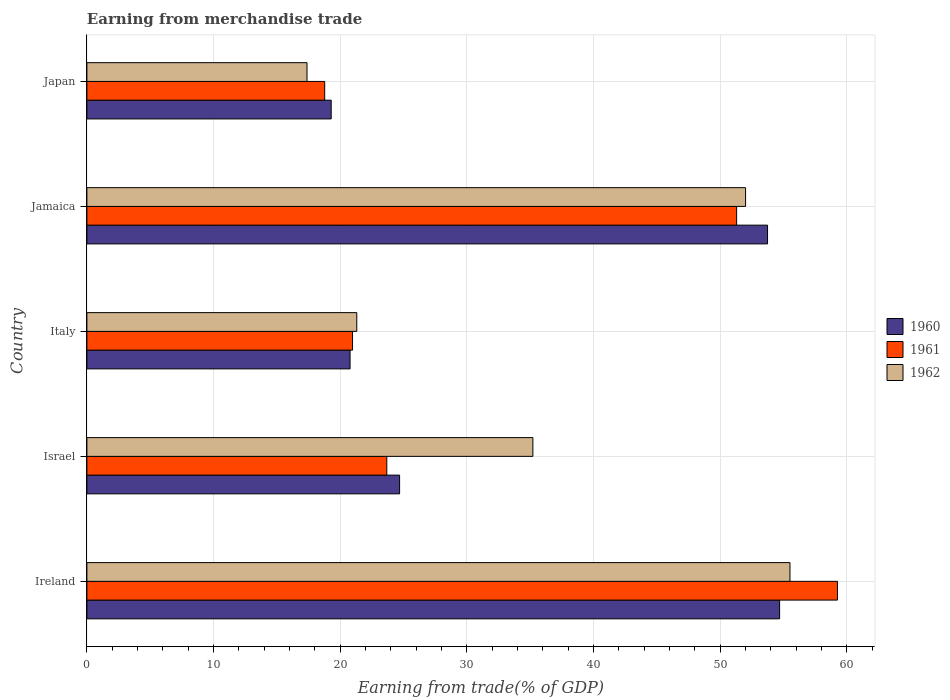Are the number of bars per tick equal to the number of legend labels?
Keep it short and to the point. Yes. Are the number of bars on each tick of the Y-axis equal?
Provide a short and direct response. Yes. How many bars are there on the 2nd tick from the top?
Keep it short and to the point. 3. What is the label of the 2nd group of bars from the top?
Ensure brevity in your answer.  Jamaica. In how many cases, is the number of bars for a given country not equal to the number of legend labels?
Ensure brevity in your answer.  0. What is the earnings from trade in 1962 in Ireland?
Your answer should be very brief. 55.51. Across all countries, what is the maximum earnings from trade in 1961?
Your answer should be very brief. 59.26. Across all countries, what is the minimum earnings from trade in 1962?
Provide a succinct answer. 17.38. In which country was the earnings from trade in 1960 maximum?
Ensure brevity in your answer.  Ireland. In which country was the earnings from trade in 1960 minimum?
Your answer should be very brief. Japan. What is the total earnings from trade in 1961 in the graph?
Keep it short and to the point. 173.98. What is the difference between the earnings from trade in 1962 in Israel and that in Italy?
Offer a terse response. 13.9. What is the difference between the earnings from trade in 1960 in Israel and the earnings from trade in 1962 in Ireland?
Give a very brief answer. -30.82. What is the average earnings from trade in 1960 per country?
Provide a succinct answer. 34.64. What is the difference between the earnings from trade in 1962 and earnings from trade in 1961 in Ireland?
Provide a succinct answer. -3.75. What is the ratio of the earnings from trade in 1961 in Italy to that in Japan?
Your answer should be compact. 1.12. Is the difference between the earnings from trade in 1962 in Israel and Italy greater than the difference between the earnings from trade in 1961 in Israel and Italy?
Make the answer very short. Yes. What is the difference between the highest and the second highest earnings from trade in 1961?
Offer a terse response. 7.96. What is the difference between the highest and the lowest earnings from trade in 1962?
Ensure brevity in your answer.  38.13. What does the 1st bar from the bottom in Italy represents?
Give a very brief answer. 1960. How many bars are there?
Provide a succinct answer. 15. How many countries are there in the graph?
Make the answer very short. 5. What is the difference between two consecutive major ticks on the X-axis?
Offer a very short reply. 10. Are the values on the major ticks of X-axis written in scientific E-notation?
Make the answer very short. No. Does the graph contain grids?
Keep it short and to the point. Yes. Where does the legend appear in the graph?
Ensure brevity in your answer.  Center right. How many legend labels are there?
Your response must be concise. 3. How are the legend labels stacked?
Your answer should be compact. Vertical. What is the title of the graph?
Offer a terse response. Earning from merchandise trade. What is the label or title of the X-axis?
Ensure brevity in your answer.  Earning from trade(% of GDP). What is the Earning from trade(% of GDP) of 1960 in Ireland?
Make the answer very short. 54.69. What is the Earning from trade(% of GDP) in 1961 in Ireland?
Make the answer very short. 59.26. What is the Earning from trade(% of GDP) of 1962 in Ireland?
Your response must be concise. 55.51. What is the Earning from trade(% of GDP) of 1960 in Israel?
Keep it short and to the point. 24.69. What is the Earning from trade(% of GDP) of 1961 in Israel?
Provide a succinct answer. 23.68. What is the Earning from trade(% of GDP) of 1962 in Israel?
Your response must be concise. 35.21. What is the Earning from trade(% of GDP) in 1960 in Italy?
Provide a succinct answer. 20.78. What is the Earning from trade(% of GDP) of 1961 in Italy?
Your answer should be very brief. 20.97. What is the Earning from trade(% of GDP) in 1962 in Italy?
Your response must be concise. 21.31. What is the Earning from trade(% of GDP) in 1960 in Jamaica?
Provide a succinct answer. 53.74. What is the Earning from trade(% of GDP) of 1961 in Jamaica?
Provide a succinct answer. 51.3. What is the Earning from trade(% of GDP) in 1962 in Jamaica?
Your response must be concise. 52. What is the Earning from trade(% of GDP) in 1960 in Japan?
Provide a succinct answer. 19.29. What is the Earning from trade(% of GDP) of 1961 in Japan?
Provide a short and direct response. 18.77. What is the Earning from trade(% of GDP) of 1962 in Japan?
Make the answer very short. 17.38. Across all countries, what is the maximum Earning from trade(% of GDP) in 1960?
Your answer should be very brief. 54.69. Across all countries, what is the maximum Earning from trade(% of GDP) in 1961?
Your response must be concise. 59.26. Across all countries, what is the maximum Earning from trade(% of GDP) in 1962?
Provide a succinct answer. 55.51. Across all countries, what is the minimum Earning from trade(% of GDP) in 1960?
Provide a succinct answer. 19.29. Across all countries, what is the minimum Earning from trade(% of GDP) of 1961?
Provide a short and direct response. 18.77. Across all countries, what is the minimum Earning from trade(% of GDP) of 1962?
Offer a very short reply. 17.38. What is the total Earning from trade(% of GDP) of 1960 in the graph?
Keep it short and to the point. 173.18. What is the total Earning from trade(% of GDP) of 1961 in the graph?
Your answer should be compact. 173.98. What is the total Earning from trade(% of GDP) of 1962 in the graph?
Your response must be concise. 181.41. What is the difference between the Earning from trade(% of GDP) in 1960 in Ireland and that in Israel?
Offer a very short reply. 30. What is the difference between the Earning from trade(% of GDP) of 1961 in Ireland and that in Israel?
Your response must be concise. 35.58. What is the difference between the Earning from trade(% of GDP) of 1962 in Ireland and that in Israel?
Offer a terse response. 20.3. What is the difference between the Earning from trade(% of GDP) of 1960 in Ireland and that in Italy?
Provide a succinct answer. 33.91. What is the difference between the Earning from trade(% of GDP) of 1961 in Ireland and that in Italy?
Your response must be concise. 38.29. What is the difference between the Earning from trade(% of GDP) in 1962 in Ireland and that in Italy?
Give a very brief answer. 34.2. What is the difference between the Earning from trade(% of GDP) of 1960 in Ireland and that in Jamaica?
Offer a very short reply. 0.95. What is the difference between the Earning from trade(% of GDP) of 1961 in Ireland and that in Jamaica?
Keep it short and to the point. 7.96. What is the difference between the Earning from trade(% of GDP) of 1962 in Ireland and that in Jamaica?
Provide a short and direct response. 3.5. What is the difference between the Earning from trade(% of GDP) in 1960 in Ireland and that in Japan?
Offer a terse response. 35.4. What is the difference between the Earning from trade(% of GDP) in 1961 in Ireland and that in Japan?
Keep it short and to the point. 40.48. What is the difference between the Earning from trade(% of GDP) of 1962 in Ireland and that in Japan?
Make the answer very short. 38.13. What is the difference between the Earning from trade(% of GDP) in 1960 in Israel and that in Italy?
Your response must be concise. 3.91. What is the difference between the Earning from trade(% of GDP) in 1961 in Israel and that in Italy?
Offer a terse response. 2.71. What is the difference between the Earning from trade(% of GDP) of 1962 in Israel and that in Italy?
Offer a terse response. 13.9. What is the difference between the Earning from trade(% of GDP) in 1960 in Israel and that in Jamaica?
Provide a succinct answer. -29.05. What is the difference between the Earning from trade(% of GDP) in 1961 in Israel and that in Jamaica?
Offer a very short reply. -27.62. What is the difference between the Earning from trade(% of GDP) of 1962 in Israel and that in Jamaica?
Your answer should be very brief. -16.79. What is the difference between the Earning from trade(% of GDP) of 1960 in Israel and that in Japan?
Offer a very short reply. 5.4. What is the difference between the Earning from trade(% of GDP) in 1961 in Israel and that in Japan?
Give a very brief answer. 4.9. What is the difference between the Earning from trade(% of GDP) of 1962 in Israel and that in Japan?
Your answer should be very brief. 17.83. What is the difference between the Earning from trade(% of GDP) of 1960 in Italy and that in Jamaica?
Your answer should be very brief. -32.96. What is the difference between the Earning from trade(% of GDP) in 1961 in Italy and that in Jamaica?
Offer a very short reply. -30.32. What is the difference between the Earning from trade(% of GDP) in 1962 in Italy and that in Jamaica?
Offer a very short reply. -30.7. What is the difference between the Earning from trade(% of GDP) in 1960 in Italy and that in Japan?
Ensure brevity in your answer.  1.49. What is the difference between the Earning from trade(% of GDP) in 1961 in Italy and that in Japan?
Ensure brevity in your answer.  2.2. What is the difference between the Earning from trade(% of GDP) of 1962 in Italy and that in Japan?
Your answer should be compact. 3.93. What is the difference between the Earning from trade(% of GDP) of 1960 in Jamaica and that in Japan?
Your answer should be compact. 34.45. What is the difference between the Earning from trade(% of GDP) of 1961 in Jamaica and that in Japan?
Offer a very short reply. 32.52. What is the difference between the Earning from trade(% of GDP) of 1962 in Jamaica and that in Japan?
Give a very brief answer. 34.63. What is the difference between the Earning from trade(% of GDP) in 1960 in Ireland and the Earning from trade(% of GDP) in 1961 in Israel?
Give a very brief answer. 31.01. What is the difference between the Earning from trade(% of GDP) of 1960 in Ireland and the Earning from trade(% of GDP) of 1962 in Israel?
Your answer should be compact. 19.48. What is the difference between the Earning from trade(% of GDP) in 1961 in Ireland and the Earning from trade(% of GDP) in 1962 in Israel?
Offer a terse response. 24.05. What is the difference between the Earning from trade(% of GDP) in 1960 in Ireland and the Earning from trade(% of GDP) in 1961 in Italy?
Offer a terse response. 33.72. What is the difference between the Earning from trade(% of GDP) in 1960 in Ireland and the Earning from trade(% of GDP) in 1962 in Italy?
Give a very brief answer. 33.38. What is the difference between the Earning from trade(% of GDP) in 1961 in Ireland and the Earning from trade(% of GDP) in 1962 in Italy?
Provide a short and direct response. 37.95. What is the difference between the Earning from trade(% of GDP) in 1960 in Ireland and the Earning from trade(% of GDP) in 1961 in Jamaica?
Your answer should be very brief. 3.39. What is the difference between the Earning from trade(% of GDP) in 1960 in Ireland and the Earning from trade(% of GDP) in 1962 in Jamaica?
Your response must be concise. 2.69. What is the difference between the Earning from trade(% of GDP) in 1961 in Ireland and the Earning from trade(% of GDP) in 1962 in Jamaica?
Keep it short and to the point. 7.25. What is the difference between the Earning from trade(% of GDP) of 1960 in Ireland and the Earning from trade(% of GDP) of 1961 in Japan?
Provide a succinct answer. 35.92. What is the difference between the Earning from trade(% of GDP) of 1960 in Ireland and the Earning from trade(% of GDP) of 1962 in Japan?
Keep it short and to the point. 37.31. What is the difference between the Earning from trade(% of GDP) of 1961 in Ireland and the Earning from trade(% of GDP) of 1962 in Japan?
Ensure brevity in your answer.  41.88. What is the difference between the Earning from trade(% of GDP) in 1960 in Israel and the Earning from trade(% of GDP) in 1961 in Italy?
Make the answer very short. 3.72. What is the difference between the Earning from trade(% of GDP) of 1960 in Israel and the Earning from trade(% of GDP) of 1962 in Italy?
Your answer should be very brief. 3.38. What is the difference between the Earning from trade(% of GDP) in 1961 in Israel and the Earning from trade(% of GDP) in 1962 in Italy?
Ensure brevity in your answer.  2.37. What is the difference between the Earning from trade(% of GDP) in 1960 in Israel and the Earning from trade(% of GDP) in 1961 in Jamaica?
Offer a terse response. -26.61. What is the difference between the Earning from trade(% of GDP) in 1960 in Israel and the Earning from trade(% of GDP) in 1962 in Jamaica?
Your answer should be very brief. -27.32. What is the difference between the Earning from trade(% of GDP) in 1961 in Israel and the Earning from trade(% of GDP) in 1962 in Jamaica?
Offer a terse response. -28.33. What is the difference between the Earning from trade(% of GDP) of 1960 in Israel and the Earning from trade(% of GDP) of 1961 in Japan?
Give a very brief answer. 5.91. What is the difference between the Earning from trade(% of GDP) in 1960 in Israel and the Earning from trade(% of GDP) in 1962 in Japan?
Give a very brief answer. 7.31. What is the difference between the Earning from trade(% of GDP) in 1961 in Israel and the Earning from trade(% of GDP) in 1962 in Japan?
Offer a terse response. 6.3. What is the difference between the Earning from trade(% of GDP) in 1960 in Italy and the Earning from trade(% of GDP) in 1961 in Jamaica?
Make the answer very short. -30.52. What is the difference between the Earning from trade(% of GDP) in 1960 in Italy and the Earning from trade(% of GDP) in 1962 in Jamaica?
Your response must be concise. -31.23. What is the difference between the Earning from trade(% of GDP) of 1961 in Italy and the Earning from trade(% of GDP) of 1962 in Jamaica?
Keep it short and to the point. -31.03. What is the difference between the Earning from trade(% of GDP) in 1960 in Italy and the Earning from trade(% of GDP) in 1961 in Japan?
Offer a terse response. 2. What is the difference between the Earning from trade(% of GDP) of 1960 in Italy and the Earning from trade(% of GDP) of 1962 in Japan?
Keep it short and to the point. 3.4. What is the difference between the Earning from trade(% of GDP) of 1961 in Italy and the Earning from trade(% of GDP) of 1962 in Japan?
Provide a short and direct response. 3.59. What is the difference between the Earning from trade(% of GDP) of 1960 in Jamaica and the Earning from trade(% of GDP) of 1961 in Japan?
Your response must be concise. 34.96. What is the difference between the Earning from trade(% of GDP) of 1960 in Jamaica and the Earning from trade(% of GDP) of 1962 in Japan?
Keep it short and to the point. 36.36. What is the difference between the Earning from trade(% of GDP) of 1961 in Jamaica and the Earning from trade(% of GDP) of 1962 in Japan?
Offer a very short reply. 33.92. What is the average Earning from trade(% of GDP) of 1960 per country?
Keep it short and to the point. 34.64. What is the average Earning from trade(% of GDP) of 1961 per country?
Your answer should be compact. 34.8. What is the average Earning from trade(% of GDP) in 1962 per country?
Ensure brevity in your answer.  36.28. What is the difference between the Earning from trade(% of GDP) of 1960 and Earning from trade(% of GDP) of 1961 in Ireland?
Offer a terse response. -4.57. What is the difference between the Earning from trade(% of GDP) in 1960 and Earning from trade(% of GDP) in 1962 in Ireland?
Keep it short and to the point. -0.82. What is the difference between the Earning from trade(% of GDP) in 1961 and Earning from trade(% of GDP) in 1962 in Ireland?
Offer a very short reply. 3.75. What is the difference between the Earning from trade(% of GDP) of 1960 and Earning from trade(% of GDP) of 1961 in Israel?
Your response must be concise. 1.01. What is the difference between the Earning from trade(% of GDP) of 1960 and Earning from trade(% of GDP) of 1962 in Israel?
Offer a terse response. -10.52. What is the difference between the Earning from trade(% of GDP) of 1961 and Earning from trade(% of GDP) of 1962 in Israel?
Keep it short and to the point. -11.53. What is the difference between the Earning from trade(% of GDP) in 1960 and Earning from trade(% of GDP) in 1961 in Italy?
Keep it short and to the point. -0.2. What is the difference between the Earning from trade(% of GDP) of 1960 and Earning from trade(% of GDP) of 1962 in Italy?
Make the answer very short. -0.53. What is the difference between the Earning from trade(% of GDP) of 1961 and Earning from trade(% of GDP) of 1962 in Italy?
Keep it short and to the point. -0.34. What is the difference between the Earning from trade(% of GDP) in 1960 and Earning from trade(% of GDP) in 1961 in Jamaica?
Provide a short and direct response. 2.44. What is the difference between the Earning from trade(% of GDP) in 1960 and Earning from trade(% of GDP) in 1962 in Jamaica?
Keep it short and to the point. 1.73. What is the difference between the Earning from trade(% of GDP) in 1961 and Earning from trade(% of GDP) in 1962 in Jamaica?
Provide a succinct answer. -0.71. What is the difference between the Earning from trade(% of GDP) of 1960 and Earning from trade(% of GDP) of 1961 in Japan?
Provide a succinct answer. 0.51. What is the difference between the Earning from trade(% of GDP) of 1960 and Earning from trade(% of GDP) of 1962 in Japan?
Give a very brief answer. 1.91. What is the difference between the Earning from trade(% of GDP) in 1961 and Earning from trade(% of GDP) in 1962 in Japan?
Make the answer very short. 1.4. What is the ratio of the Earning from trade(% of GDP) of 1960 in Ireland to that in Israel?
Your response must be concise. 2.22. What is the ratio of the Earning from trade(% of GDP) of 1961 in Ireland to that in Israel?
Your answer should be compact. 2.5. What is the ratio of the Earning from trade(% of GDP) in 1962 in Ireland to that in Israel?
Offer a very short reply. 1.58. What is the ratio of the Earning from trade(% of GDP) in 1960 in Ireland to that in Italy?
Provide a succinct answer. 2.63. What is the ratio of the Earning from trade(% of GDP) in 1961 in Ireland to that in Italy?
Ensure brevity in your answer.  2.83. What is the ratio of the Earning from trade(% of GDP) in 1962 in Ireland to that in Italy?
Offer a very short reply. 2.6. What is the ratio of the Earning from trade(% of GDP) in 1960 in Ireland to that in Jamaica?
Offer a terse response. 1.02. What is the ratio of the Earning from trade(% of GDP) in 1961 in Ireland to that in Jamaica?
Your answer should be compact. 1.16. What is the ratio of the Earning from trade(% of GDP) in 1962 in Ireland to that in Jamaica?
Make the answer very short. 1.07. What is the ratio of the Earning from trade(% of GDP) in 1960 in Ireland to that in Japan?
Offer a terse response. 2.84. What is the ratio of the Earning from trade(% of GDP) in 1961 in Ireland to that in Japan?
Your answer should be very brief. 3.16. What is the ratio of the Earning from trade(% of GDP) in 1962 in Ireland to that in Japan?
Provide a succinct answer. 3.19. What is the ratio of the Earning from trade(% of GDP) in 1960 in Israel to that in Italy?
Provide a short and direct response. 1.19. What is the ratio of the Earning from trade(% of GDP) of 1961 in Israel to that in Italy?
Ensure brevity in your answer.  1.13. What is the ratio of the Earning from trade(% of GDP) of 1962 in Israel to that in Italy?
Give a very brief answer. 1.65. What is the ratio of the Earning from trade(% of GDP) of 1960 in Israel to that in Jamaica?
Keep it short and to the point. 0.46. What is the ratio of the Earning from trade(% of GDP) in 1961 in Israel to that in Jamaica?
Your answer should be very brief. 0.46. What is the ratio of the Earning from trade(% of GDP) of 1962 in Israel to that in Jamaica?
Give a very brief answer. 0.68. What is the ratio of the Earning from trade(% of GDP) in 1960 in Israel to that in Japan?
Your answer should be compact. 1.28. What is the ratio of the Earning from trade(% of GDP) of 1961 in Israel to that in Japan?
Ensure brevity in your answer.  1.26. What is the ratio of the Earning from trade(% of GDP) of 1962 in Israel to that in Japan?
Offer a very short reply. 2.03. What is the ratio of the Earning from trade(% of GDP) in 1960 in Italy to that in Jamaica?
Provide a succinct answer. 0.39. What is the ratio of the Earning from trade(% of GDP) of 1961 in Italy to that in Jamaica?
Your answer should be compact. 0.41. What is the ratio of the Earning from trade(% of GDP) in 1962 in Italy to that in Jamaica?
Give a very brief answer. 0.41. What is the ratio of the Earning from trade(% of GDP) in 1960 in Italy to that in Japan?
Your answer should be very brief. 1.08. What is the ratio of the Earning from trade(% of GDP) in 1961 in Italy to that in Japan?
Offer a very short reply. 1.12. What is the ratio of the Earning from trade(% of GDP) in 1962 in Italy to that in Japan?
Offer a very short reply. 1.23. What is the ratio of the Earning from trade(% of GDP) of 1960 in Jamaica to that in Japan?
Provide a succinct answer. 2.79. What is the ratio of the Earning from trade(% of GDP) of 1961 in Jamaica to that in Japan?
Your answer should be compact. 2.73. What is the ratio of the Earning from trade(% of GDP) of 1962 in Jamaica to that in Japan?
Provide a short and direct response. 2.99. What is the difference between the highest and the second highest Earning from trade(% of GDP) of 1960?
Offer a terse response. 0.95. What is the difference between the highest and the second highest Earning from trade(% of GDP) in 1961?
Ensure brevity in your answer.  7.96. What is the difference between the highest and the second highest Earning from trade(% of GDP) of 1962?
Give a very brief answer. 3.5. What is the difference between the highest and the lowest Earning from trade(% of GDP) in 1960?
Your answer should be compact. 35.4. What is the difference between the highest and the lowest Earning from trade(% of GDP) of 1961?
Keep it short and to the point. 40.48. What is the difference between the highest and the lowest Earning from trade(% of GDP) of 1962?
Give a very brief answer. 38.13. 